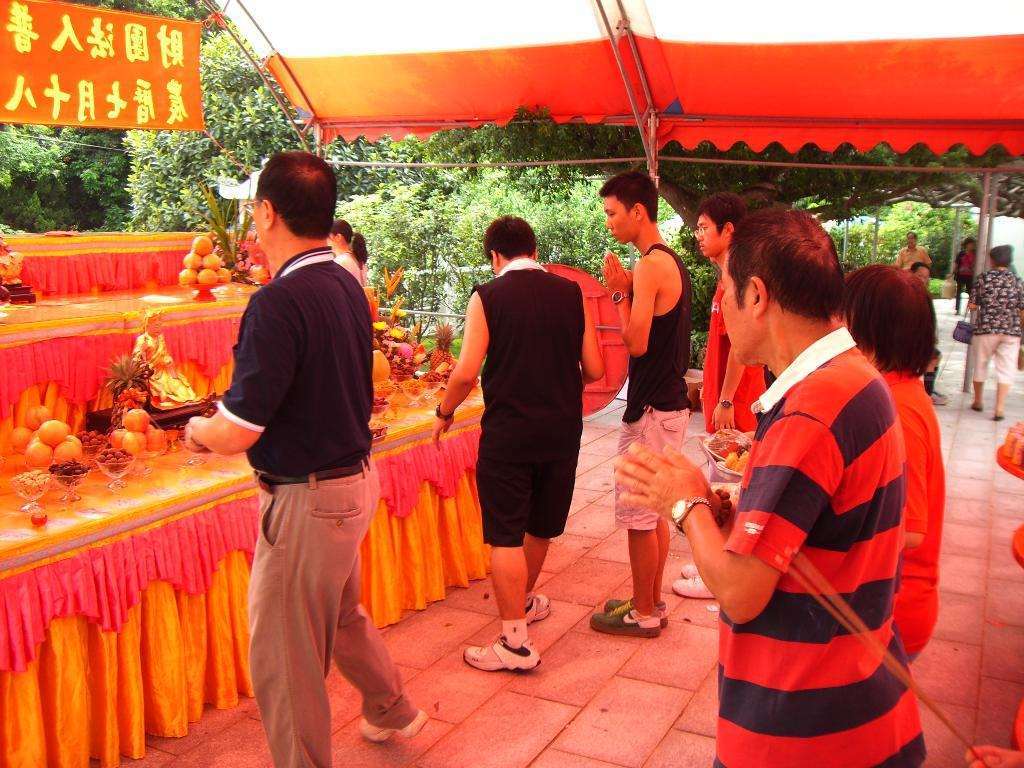How many people are in the image? There is a group of people in the image, but the exact number is not specified. What is the position of the people in the image? The people are standing on the ground in the image. What type of food can be seen in the image? There are bowls with fruits in the image. What type of shelter is present in the image? There is a tent in the image. What type of vegetation is present in the image? Trees are present in the image. What type of signage is present in the image? There is a banner in the image. Where is the desk located in the image? There is no desk present in the image. What type of division is visible in the image? There is no division or separation visible in the image. 